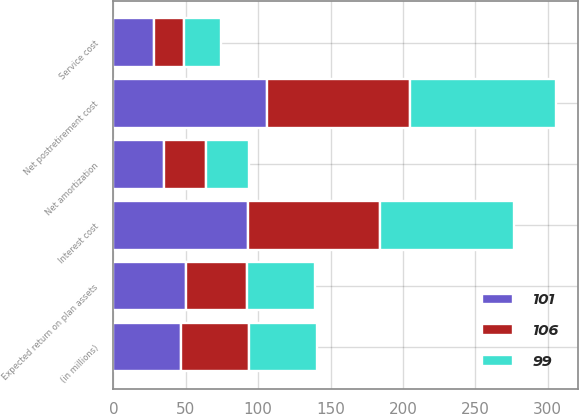Convert chart to OTSL. <chart><loc_0><loc_0><loc_500><loc_500><stacked_bar_chart><ecel><fcel>(in millions)<fcel>Service cost<fcel>Interest cost<fcel>Expected return on plan assets<fcel>Net amortization<fcel>Net postretirement cost<nl><fcel>101<fcel>47<fcel>28<fcel>93<fcel>50<fcel>35<fcel>106<nl><fcel>99<fcel>47<fcel>25<fcel>93<fcel>47<fcel>30<fcel>101<nl><fcel>106<fcel>47<fcel>21<fcel>91<fcel>42<fcel>29<fcel>99<nl></chart> 